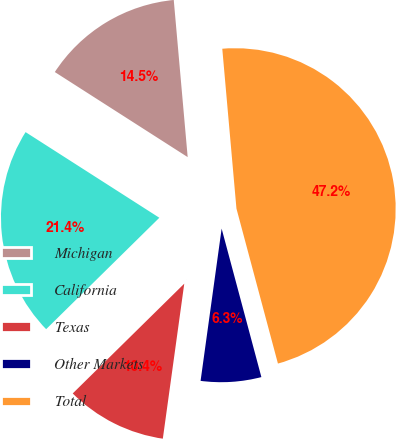<chart> <loc_0><loc_0><loc_500><loc_500><pie_chart><fcel>Michigan<fcel>California<fcel>Texas<fcel>Other Markets<fcel>Total<nl><fcel>14.53%<fcel>21.44%<fcel>10.44%<fcel>6.35%<fcel>47.25%<nl></chart> 